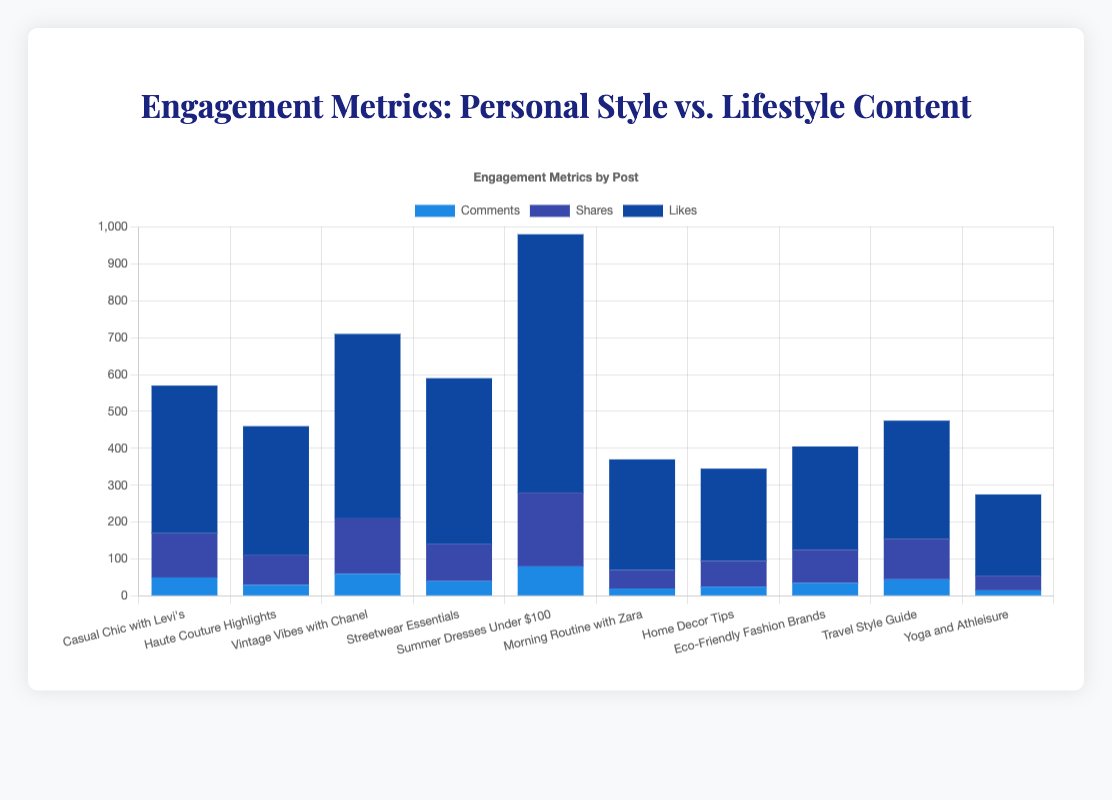What category had the highest number of comments on a single post? The highest number of comments is seen on the "Summer Dresses Under $100" post, which is categorized under "Personal Style". Therefore, the Personal Style category had the highest number of comments on a single post.
Answer: Personal Style Which post had the highest number of shares? Look at the shares bar for each post. The "Summer Dresses Under $100" post had the highest number of shares with 200 shares.
Answer: Summer Dresses Under $100 What's the total number of likes for all Personal Style posts? Sum the likes for each Personal Style post: 400 (Casual Chic with Levi's) + 350 (Haute Couture Highlights) + 500 (Vintage Vibes with Chanel) + 450 (Streetwear Essentials) + 700 (Summer Dresses Under $100) = 2400.
Answer: 2400 How do the total likes of Lifestyle posts compare to Personal Style posts? Sum the likes for all Lifestyle posts and compare them with the total likes for Personal Style posts. Lifestyle: 300 (Morning Routine with Zara) + 250 (Home Decor Tips) + 280 (Eco-Friendly Fashion Brands) + 320 (Travel Style Guide) + 220 (Yoga and Athleisure) = 1370. Personal Style: 2400. Therefore, Personal Style posts have 1030 more likes than Lifestyle posts.
Answer: Personal Style posts have more likes Which category had the post with the fewest comments? Identify the post with the fewest comments and see its category. "Yoga and Athleisure" had the fewest comments (15), and it is under the Lifestyle category.
Answer: Lifestyle What is the average number of shares across all categories? Calculate the mean of all shares: (120 + 80 + 150 + 100 + 200 + 50 + 70 + 90 + 110 + 40) / 10 = 1010 / 10 = 101.
Answer: 101 Is there any post that had an equal number of comments and shares? Check each post to see if any have the same number of comments and shares. None of the posts have identical values for comments and shares.
Answer: No For posts with “Style” in the title, which has the most likes? Check posts: ‘Casual Chic with Levi's’, ‘Streetwear Essentials’, ‘Travel Style Guide’. Casual Chic with Levi's: 400, Streetwear Essentials: 450, Travel Style Guide: 320. Streetwear Essentials has the most likes with 450.
Answer: Streetwear Essentials 